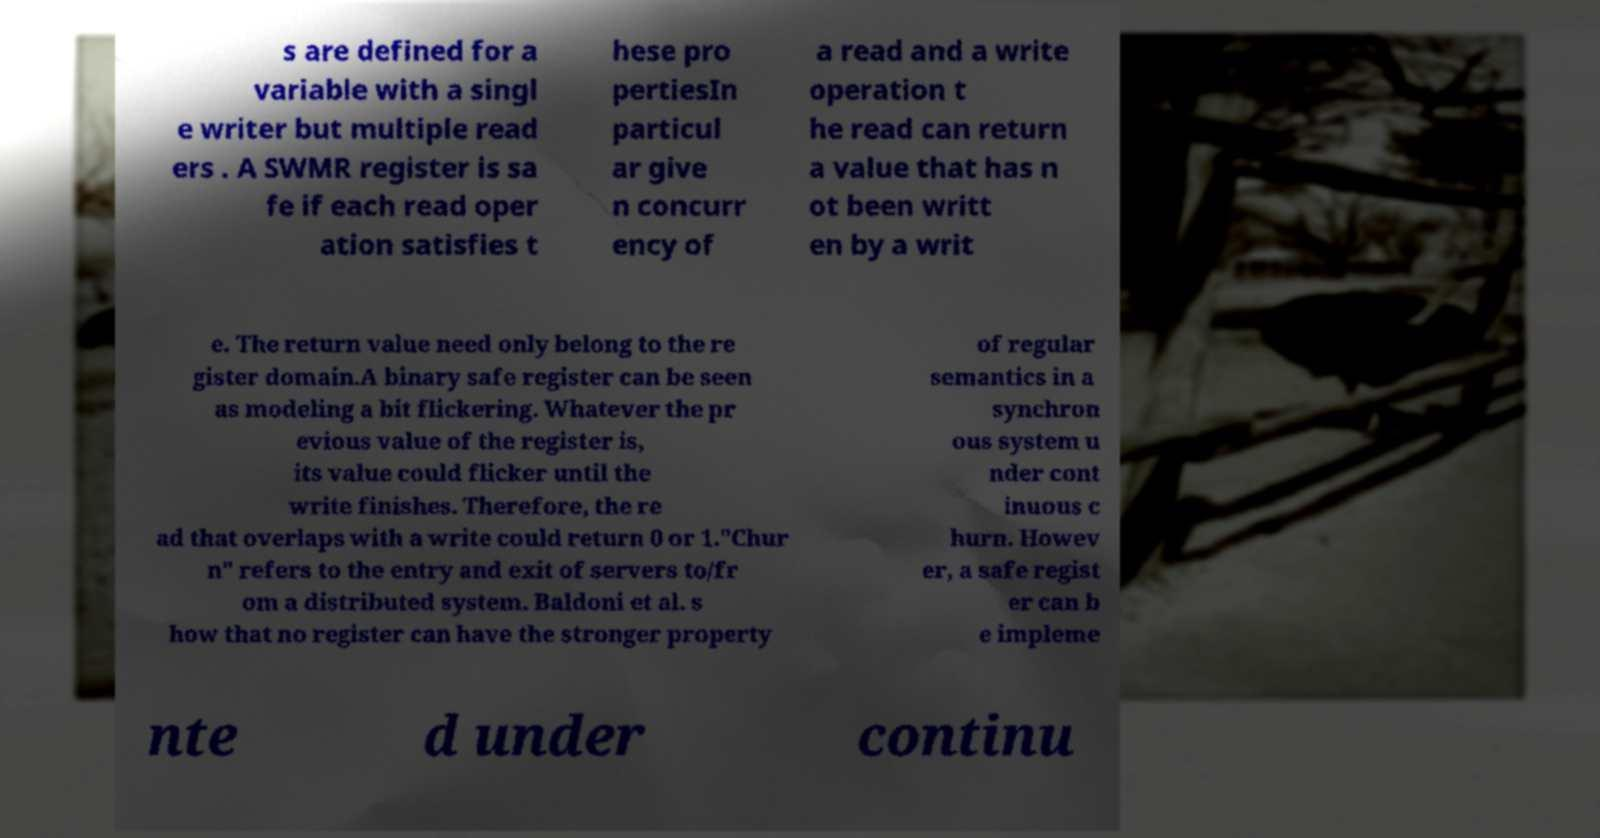I need the written content from this picture converted into text. Can you do that? s are defined for a variable with a singl e writer but multiple read ers . A SWMR register is sa fe if each read oper ation satisfies t hese pro pertiesIn particul ar give n concurr ency of a read and a write operation t he read can return a value that has n ot been writt en by a writ e. The return value need only belong to the re gister domain.A binary safe register can be seen as modeling a bit flickering. Whatever the pr evious value of the register is, its value could flicker until the write finishes. Therefore, the re ad that overlaps with a write could return 0 or 1."Chur n" refers to the entry and exit of servers to/fr om a distributed system. Baldoni et al. s how that no register can have the stronger property of regular semantics in a synchron ous system u nder cont inuous c hurn. Howev er, a safe regist er can b e impleme nte d under continu 